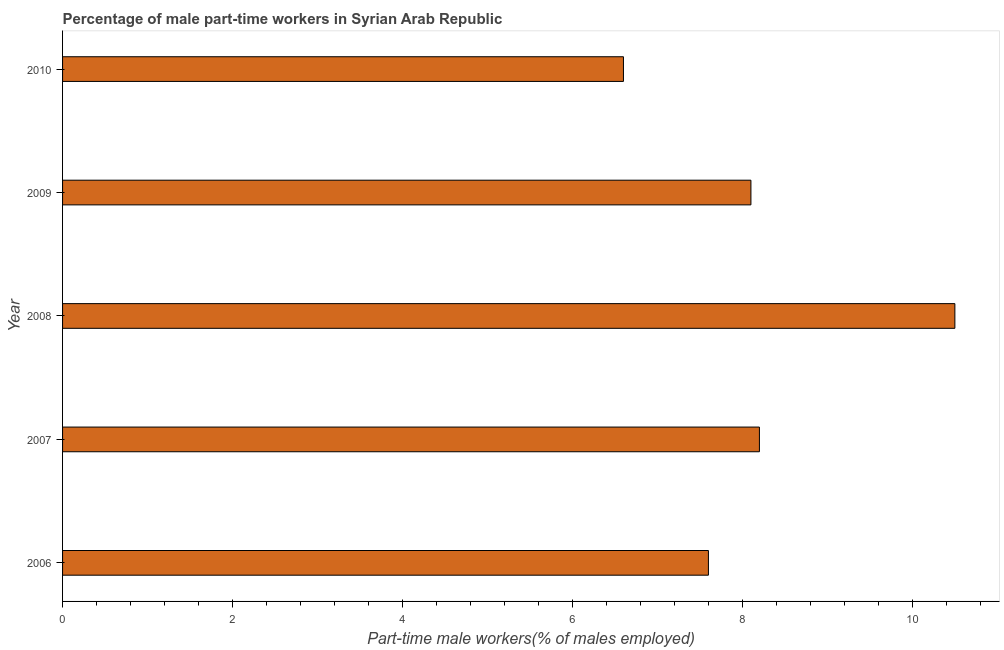Does the graph contain any zero values?
Your answer should be very brief. No. Does the graph contain grids?
Provide a succinct answer. No. What is the title of the graph?
Offer a terse response. Percentage of male part-time workers in Syrian Arab Republic. What is the label or title of the X-axis?
Provide a short and direct response. Part-time male workers(% of males employed). What is the label or title of the Y-axis?
Your response must be concise. Year. What is the percentage of part-time male workers in 2007?
Provide a succinct answer. 8.2. Across all years, what is the minimum percentage of part-time male workers?
Make the answer very short. 6.6. In which year was the percentage of part-time male workers maximum?
Your answer should be compact. 2008. What is the sum of the percentage of part-time male workers?
Your answer should be compact. 41. What is the difference between the percentage of part-time male workers in 2007 and 2010?
Ensure brevity in your answer.  1.6. What is the median percentage of part-time male workers?
Provide a short and direct response. 8.1. Do a majority of the years between 2009 and 2006 (inclusive) have percentage of part-time male workers greater than 10.4 %?
Make the answer very short. Yes. What is the ratio of the percentage of part-time male workers in 2008 to that in 2010?
Make the answer very short. 1.59. Is the percentage of part-time male workers in 2006 less than that in 2010?
Offer a very short reply. No. Is the sum of the percentage of part-time male workers in 2007 and 2010 greater than the maximum percentage of part-time male workers across all years?
Provide a succinct answer. Yes. How many bars are there?
Offer a very short reply. 5. Are all the bars in the graph horizontal?
Your response must be concise. Yes. How many years are there in the graph?
Make the answer very short. 5. What is the Part-time male workers(% of males employed) of 2006?
Your answer should be compact. 7.6. What is the Part-time male workers(% of males employed) of 2007?
Offer a very short reply. 8.2. What is the Part-time male workers(% of males employed) in 2009?
Keep it short and to the point. 8.1. What is the Part-time male workers(% of males employed) of 2010?
Your answer should be very brief. 6.6. What is the difference between the Part-time male workers(% of males employed) in 2006 and 2008?
Offer a very short reply. -2.9. What is the difference between the Part-time male workers(% of males employed) in 2007 and 2008?
Provide a short and direct response. -2.3. What is the difference between the Part-time male workers(% of males employed) in 2007 and 2009?
Offer a terse response. 0.1. What is the difference between the Part-time male workers(% of males employed) in 2007 and 2010?
Your response must be concise. 1.6. What is the difference between the Part-time male workers(% of males employed) in 2008 and 2009?
Your response must be concise. 2.4. What is the difference between the Part-time male workers(% of males employed) in 2008 and 2010?
Your answer should be compact. 3.9. What is the difference between the Part-time male workers(% of males employed) in 2009 and 2010?
Ensure brevity in your answer.  1.5. What is the ratio of the Part-time male workers(% of males employed) in 2006 to that in 2007?
Provide a short and direct response. 0.93. What is the ratio of the Part-time male workers(% of males employed) in 2006 to that in 2008?
Provide a succinct answer. 0.72. What is the ratio of the Part-time male workers(% of males employed) in 2006 to that in 2009?
Your response must be concise. 0.94. What is the ratio of the Part-time male workers(% of males employed) in 2006 to that in 2010?
Offer a very short reply. 1.15. What is the ratio of the Part-time male workers(% of males employed) in 2007 to that in 2008?
Ensure brevity in your answer.  0.78. What is the ratio of the Part-time male workers(% of males employed) in 2007 to that in 2009?
Offer a terse response. 1.01. What is the ratio of the Part-time male workers(% of males employed) in 2007 to that in 2010?
Ensure brevity in your answer.  1.24. What is the ratio of the Part-time male workers(% of males employed) in 2008 to that in 2009?
Your answer should be compact. 1.3. What is the ratio of the Part-time male workers(% of males employed) in 2008 to that in 2010?
Your answer should be very brief. 1.59. What is the ratio of the Part-time male workers(% of males employed) in 2009 to that in 2010?
Keep it short and to the point. 1.23. 